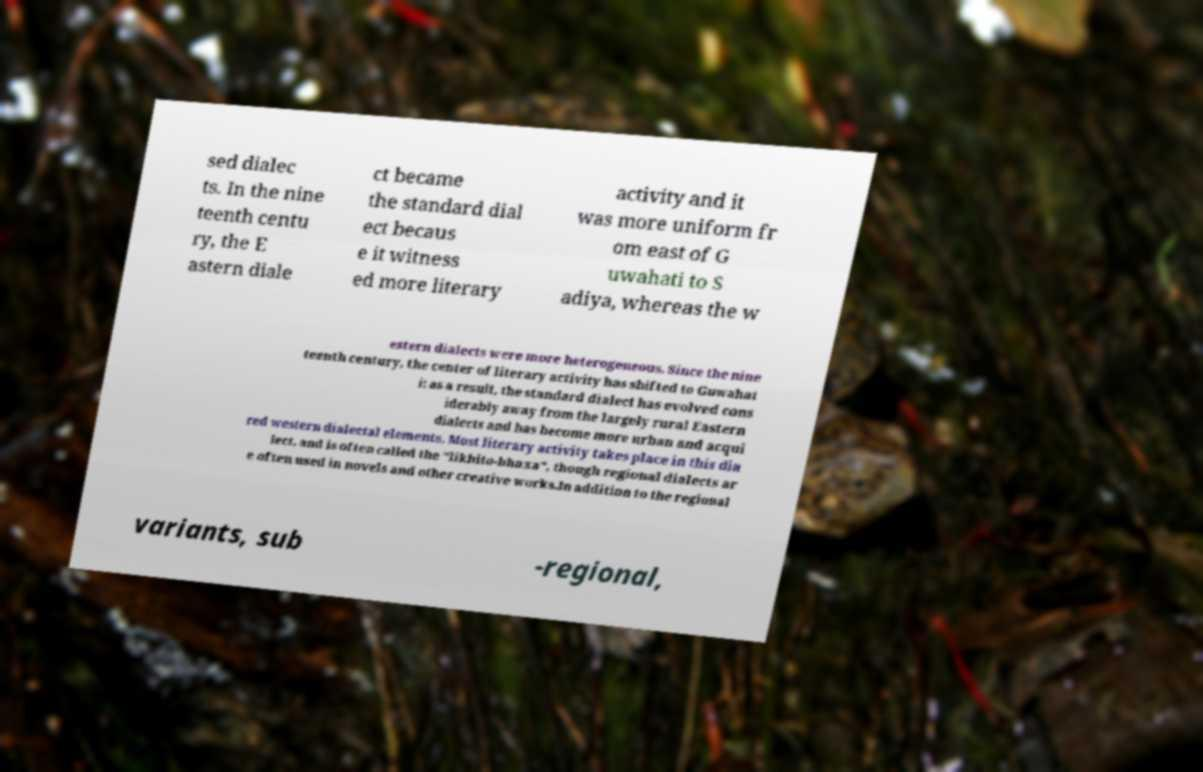Can you read and provide the text displayed in the image?This photo seems to have some interesting text. Can you extract and type it out for me? sed dialec ts. In the nine teenth centu ry, the E astern diale ct became the standard dial ect becaus e it witness ed more literary activity and it was more uniform fr om east of G uwahati to S adiya, whereas the w estern dialects were more heterogeneous. Since the nine teenth century, the center of literary activity has shifted to Guwahat i; as a result, the standard dialect has evolved cons iderably away from the largely rural Eastern dialects and has become more urban and acqui red western dialectal elements. Most literary activity takes place in this dia lect, and is often called the "likhito-bhaxa", though regional dialects ar e often used in novels and other creative works.In addition to the regional variants, sub -regional, 